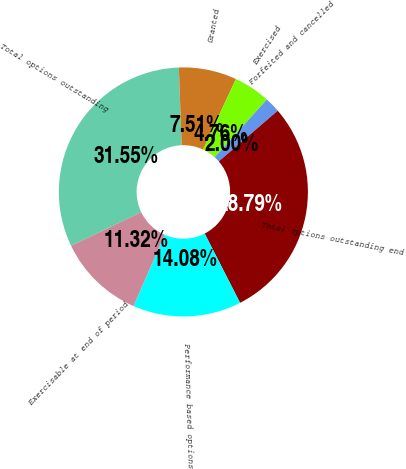<chart> <loc_0><loc_0><loc_500><loc_500><pie_chart><fcel>Total options outstanding<fcel>Granted<fcel>Exercised<fcel>Forfeited and cancelled<fcel>Total options outstanding end<fcel>Performance based options<fcel>Exercisable at end of period<nl><fcel>31.55%<fcel>7.51%<fcel>4.76%<fcel>2.0%<fcel>28.79%<fcel>14.08%<fcel>11.32%<nl></chart> 